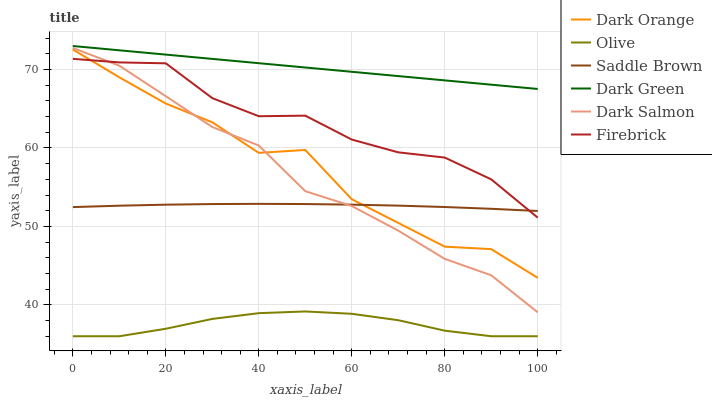Does Olive have the minimum area under the curve?
Answer yes or no. Yes. Does Dark Green have the maximum area under the curve?
Answer yes or no. Yes. Does Firebrick have the minimum area under the curve?
Answer yes or no. No. Does Firebrick have the maximum area under the curve?
Answer yes or no. No. Is Dark Green the smoothest?
Answer yes or no. Yes. Is Dark Orange the roughest?
Answer yes or no. Yes. Is Firebrick the smoothest?
Answer yes or no. No. Is Firebrick the roughest?
Answer yes or no. No. Does Olive have the lowest value?
Answer yes or no. Yes. Does Firebrick have the lowest value?
Answer yes or no. No. Does Dark Green have the highest value?
Answer yes or no. Yes. Does Firebrick have the highest value?
Answer yes or no. No. Is Olive less than Dark Salmon?
Answer yes or no. Yes. Is Firebrick greater than Olive?
Answer yes or no. Yes. Does Firebrick intersect Saddle Brown?
Answer yes or no. Yes. Is Firebrick less than Saddle Brown?
Answer yes or no. No. Is Firebrick greater than Saddle Brown?
Answer yes or no. No. Does Olive intersect Dark Salmon?
Answer yes or no. No. 